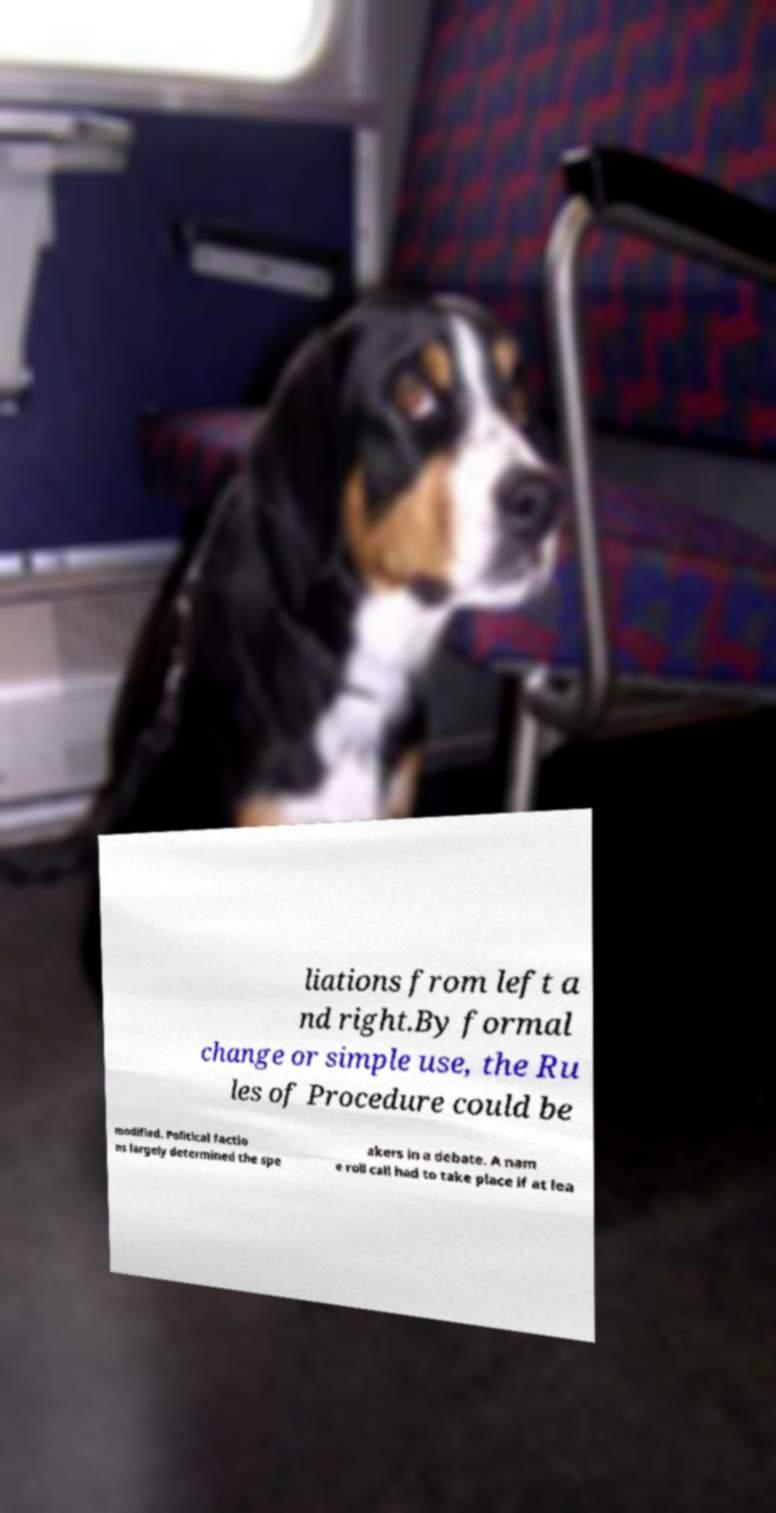Please identify and transcribe the text found in this image. liations from left a nd right.By formal change or simple use, the Ru les of Procedure could be modified. Political factio ns largely determined the spe akers in a debate. A nam e roll call had to take place if at lea 